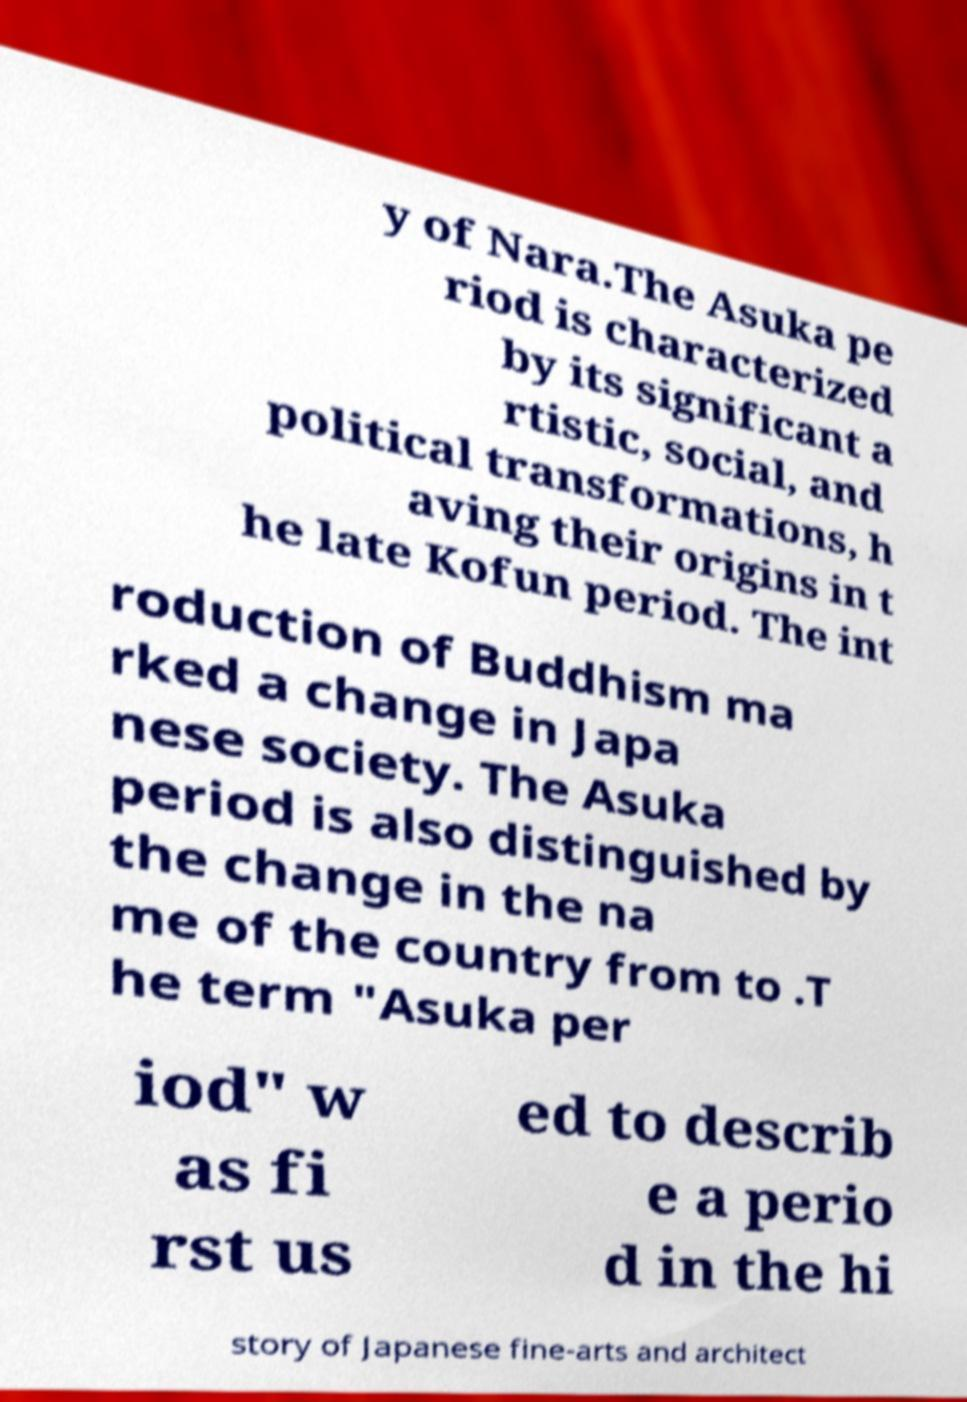Could you assist in decoding the text presented in this image and type it out clearly? y of Nara.The Asuka pe riod is characterized by its significant a rtistic, social, and political transformations, h aving their origins in t he late Kofun period. The int roduction of Buddhism ma rked a change in Japa nese society. The Asuka period is also distinguished by the change in the na me of the country from to .T he term "Asuka per iod" w as fi rst us ed to describ e a perio d in the hi story of Japanese fine-arts and architect 